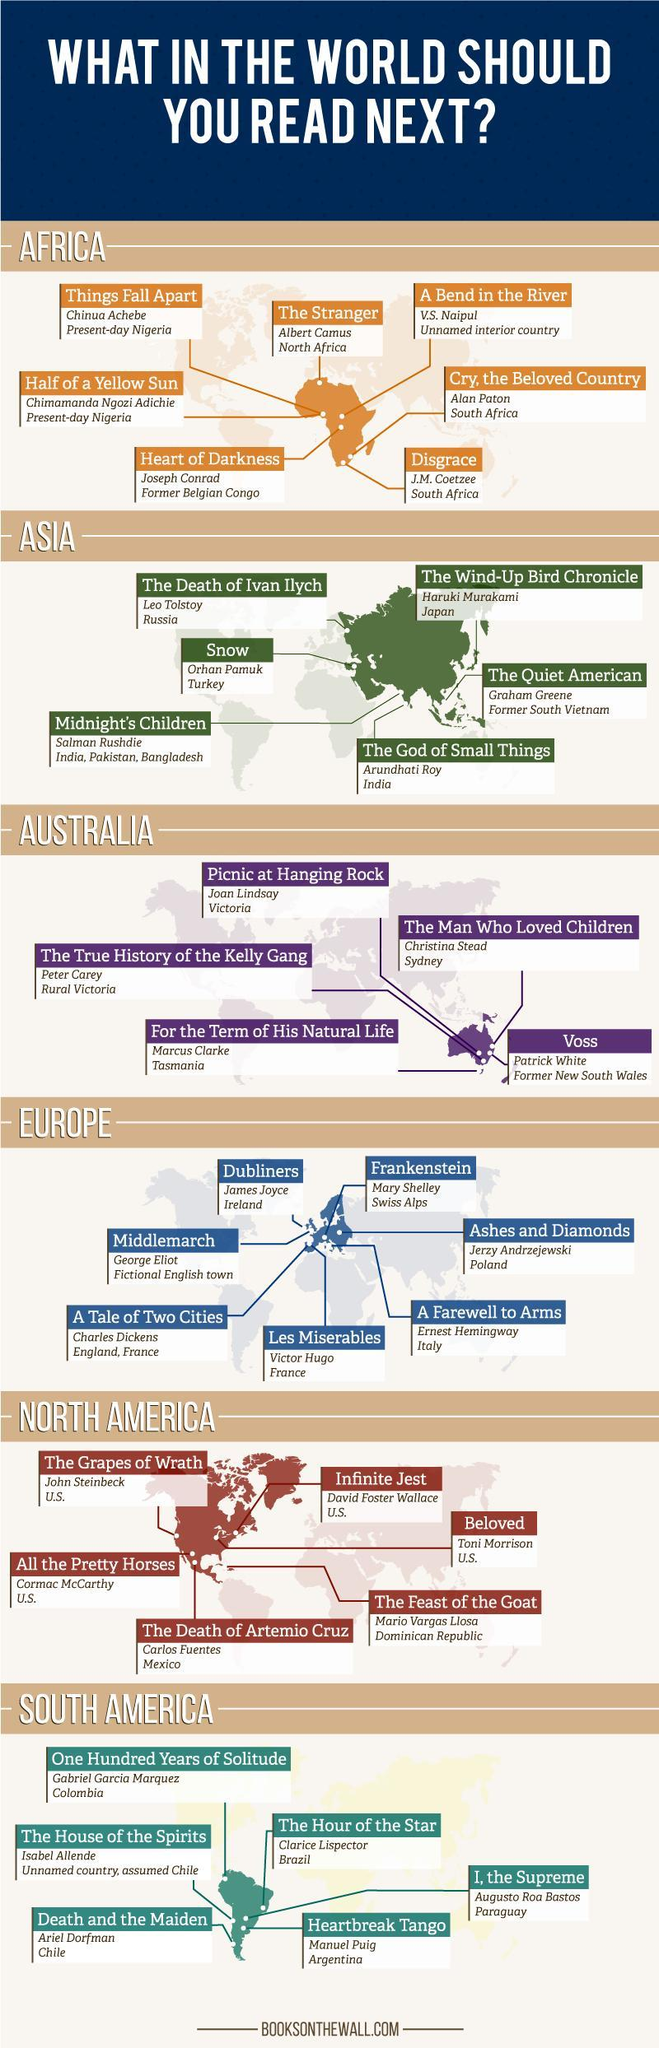Which book is written by Toni Morrison?
Answer the question with a short phrase. Beloved Who has written the book titled 'The God of Small Things'? Arundhati Roy Who has written the book titled 'Midnight's Children'? Salman Rushdie Which country's writer is Christina Stead? Australia 